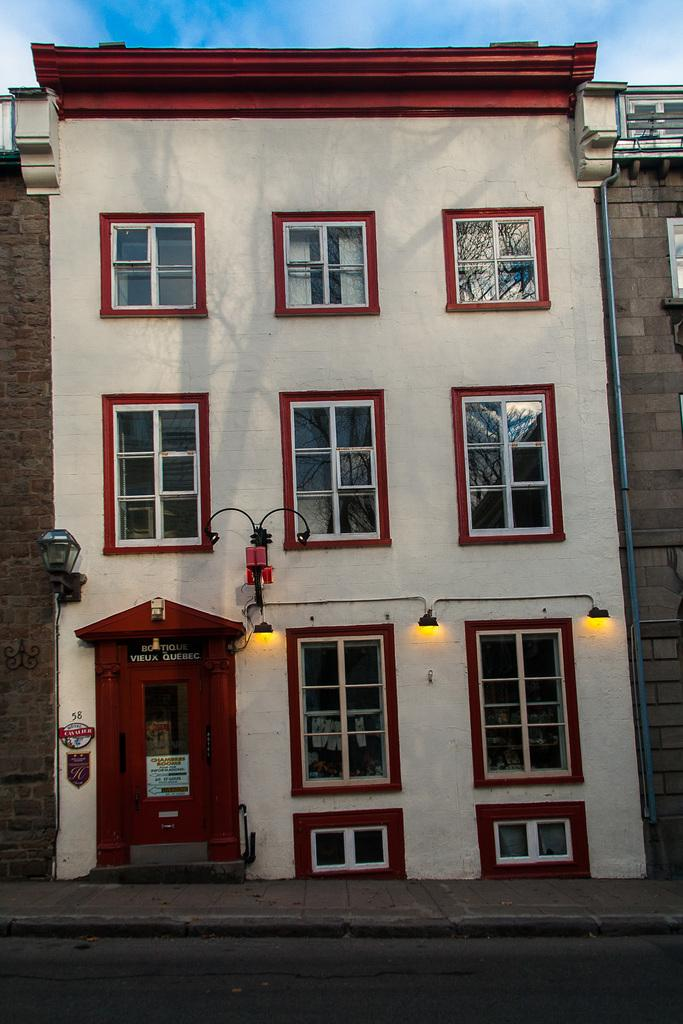What type of structure is present in the image? There is a building in the image. What are the main features of the building? The building has walls, windows, and a door. Are there any light sources visible in the image? Yes, there are lights in the image. What can be seen in the background of the image? The sky is visible in the image. What else is present in the image besides the building? There are objects in the image. What type of stone is used to build the flagpole in the image? There is no flagpole present in the image, so it is not possible to determine the type of stone used to build it. 